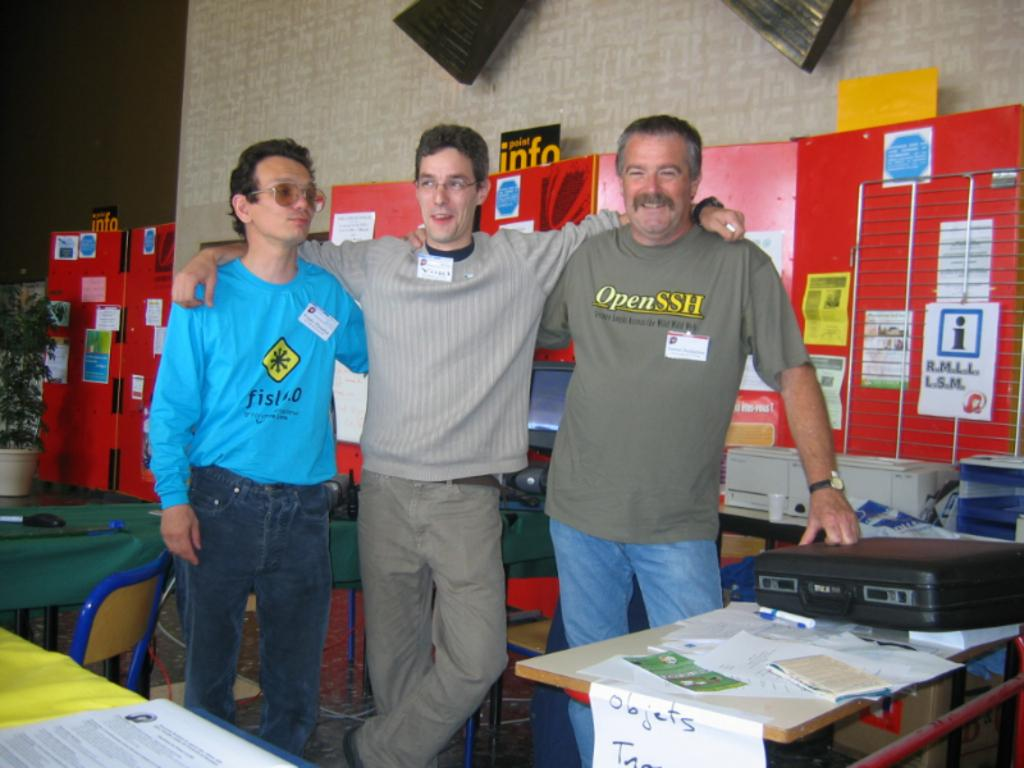How many people are in the image? There are three persons in the image. What are the persons doing in the image? The persons are standing in front of a table. What objects are near the persons and the table? Chairs are near the persons and the table. What type of loss can be seen in the image? There is no indication of loss in the image; it features three persons standing in front of a table with chairs nearby. What type of vacation is the group taking in the image? There is no indication of a vacation in the image; it simply shows three persons standing in front of a table with chairs nearby. 